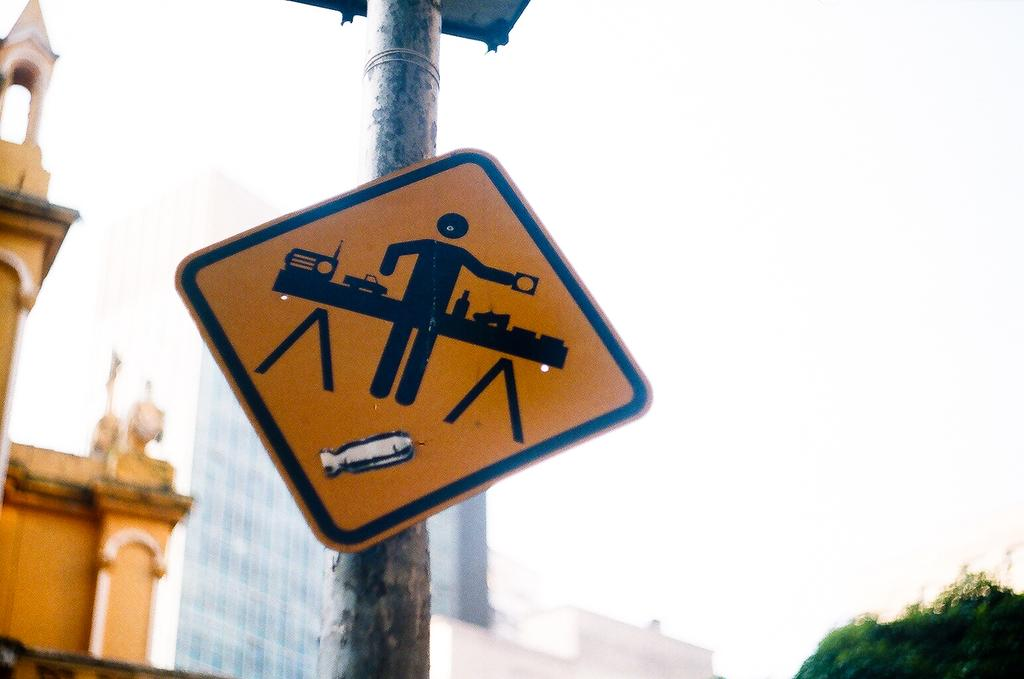What type of board is visible in the image? There is a yellow caution board in the image. How is the caution board positioned in the image? The caution board is placed on a pole. What can be seen in the background of the image? There is a big glass building in the background of the image. Where is the toothbrush located in the image? There is no toothbrush present in the image. What type of wilderness can be seen in the background of the image? There is no wilderness visible in the image; it features a big glass building in the background. 